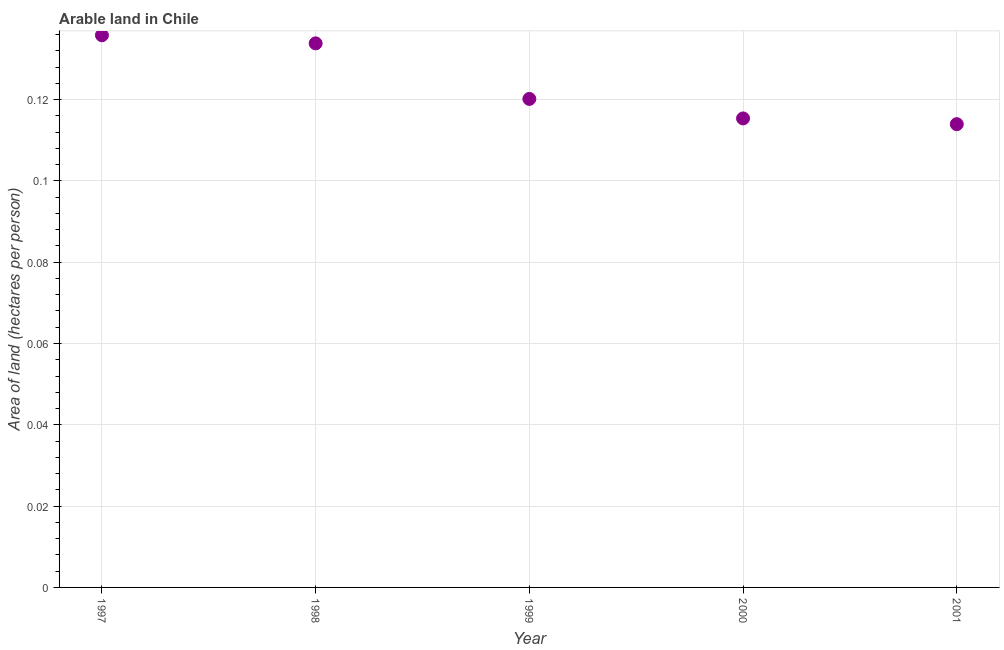What is the area of arable land in 2000?
Offer a terse response. 0.12. Across all years, what is the maximum area of arable land?
Provide a short and direct response. 0.14. Across all years, what is the minimum area of arable land?
Ensure brevity in your answer.  0.11. In which year was the area of arable land maximum?
Make the answer very short. 1997. What is the sum of the area of arable land?
Provide a short and direct response. 0.62. What is the difference between the area of arable land in 1997 and 1999?
Offer a very short reply. 0.02. What is the average area of arable land per year?
Provide a succinct answer. 0.12. What is the median area of arable land?
Offer a very short reply. 0.12. In how many years, is the area of arable land greater than 0.132 hectares per person?
Ensure brevity in your answer.  2. What is the ratio of the area of arable land in 2000 to that in 2001?
Offer a very short reply. 1.01. Is the area of arable land in 1998 less than that in 1999?
Your answer should be very brief. No. Is the difference between the area of arable land in 1998 and 2000 greater than the difference between any two years?
Make the answer very short. No. What is the difference between the highest and the second highest area of arable land?
Provide a short and direct response. 0. What is the difference between the highest and the lowest area of arable land?
Your response must be concise. 0.02. Does the area of arable land monotonically increase over the years?
Your answer should be very brief. No. What is the difference between two consecutive major ticks on the Y-axis?
Your answer should be very brief. 0.02. Are the values on the major ticks of Y-axis written in scientific E-notation?
Ensure brevity in your answer.  No. Does the graph contain any zero values?
Offer a terse response. No. Does the graph contain grids?
Your answer should be compact. Yes. What is the title of the graph?
Keep it short and to the point. Arable land in Chile. What is the label or title of the X-axis?
Provide a succinct answer. Year. What is the label or title of the Y-axis?
Your answer should be compact. Area of land (hectares per person). What is the Area of land (hectares per person) in 1997?
Keep it short and to the point. 0.14. What is the Area of land (hectares per person) in 1998?
Your answer should be compact. 0.13. What is the Area of land (hectares per person) in 1999?
Ensure brevity in your answer.  0.12. What is the Area of land (hectares per person) in 2000?
Ensure brevity in your answer.  0.12. What is the Area of land (hectares per person) in 2001?
Your response must be concise. 0.11. What is the difference between the Area of land (hectares per person) in 1997 and 1998?
Ensure brevity in your answer.  0. What is the difference between the Area of land (hectares per person) in 1997 and 1999?
Offer a terse response. 0.02. What is the difference between the Area of land (hectares per person) in 1997 and 2000?
Make the answer very short. 0.02. What is the difference between the Area of land (hectares per person) in 1997 and 2001?
Ensure brevity in your answer.  0.02. What is the difference between the Area of land (hectares per person) in 1998 and 1999?
Make the answer very short. 0.01. What is the difference between the Area of land (hectares per person) in 1998 and 2000?
Make the answer very short. 0.02. What is the difference between the Area of land (hectares per person) in 1998 and 2001?
Ensure brevity in your answer.  0.02. What is the difference between the Area of land (hectares per person) in 1999 and 2000?
Keep it short and to the point. 0. What is the difference between the Area of land (hectares per person) in 1999 and 2001?
Keep it short and to the point. 0.01. What is the difference between the Area of land (hectares per person) in 2000 and 2001?
Ensure brevity in your answer.  0. What is the ratio of the Area of land (hectares per person) in 1997 to that in 1998?
Ensure brevity in your answer.  1.01. What is the ratio of the Area of land (hectares per person) in 1997 to that in 1999?
Offer a terse response. 1.13. What is the ratio of the Area of land (hectares per person) in 1997 to that in 2000?
Offer a terse response. 1.18. What is the ratio of the Area of land (hectares per person) in 1997 to that in 2001?
Your answer should be compact. 1.19. What is the ratio of the Area of land (hectares per person) in 1998 to that in 1999?
Make the answer very short. 1.11. What is the ratio of the Area of land (hectares per person) in 1998 to that in 2000?
Keep it short and to the point. 1.16. What is the ratio of the Area of land (hectares per person) in 1998 to that in 2001?
Give a very brief answer. 1.17. What is the ratio of the Area of land (hectares per person) in 1999 to that in 2000?
Keep it short and to the point. 1.04. What is the ratio of the Area of land (hectares per person) in 1999 to that in 2001?
Offer a terse response. 1.05. What is the ratio of the Area of land (hectares per person) in 2000 to that in 2001?
Make the answer very short. 1.01. 